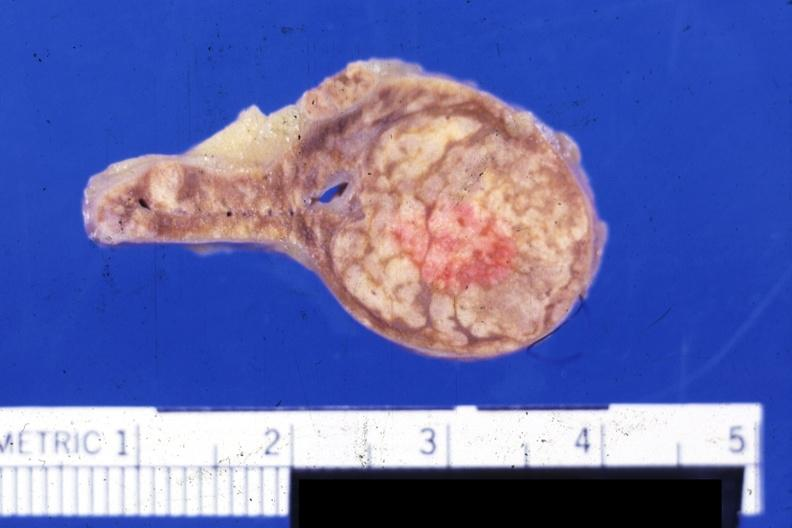does this image show fixed tissue nice close-up of moderate size cortical nodule or adenoma?
Answer the question using a single word or phrase. Yes 